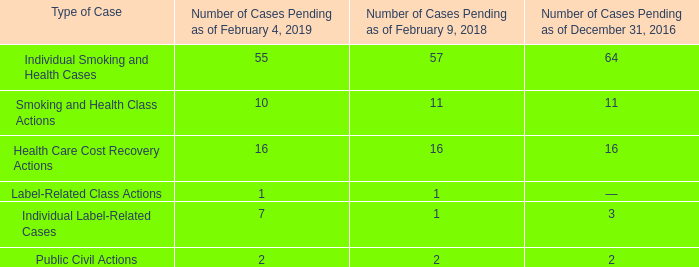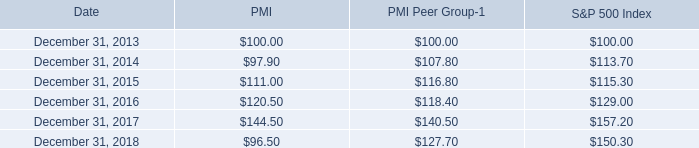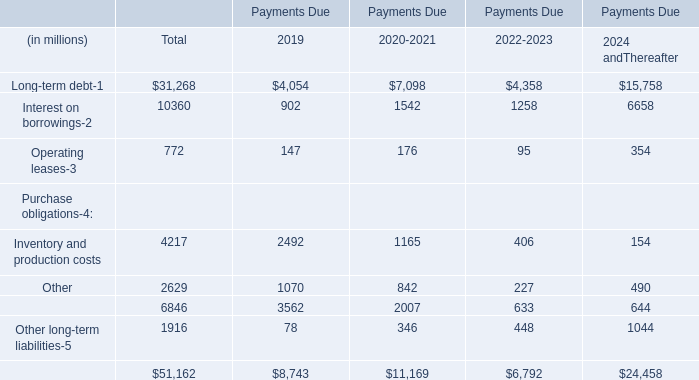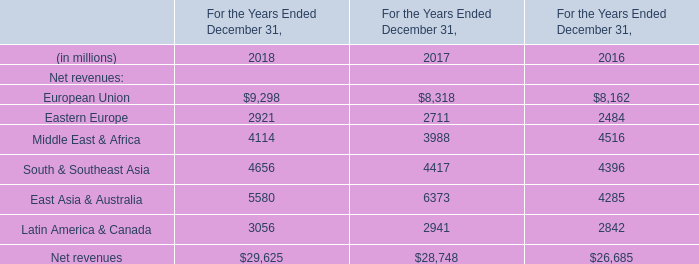what is the roi of an investment in pmi from 2013 to 2014? 
Computations: ((97.90 - 100) / 100)
Answer: -0.021. 